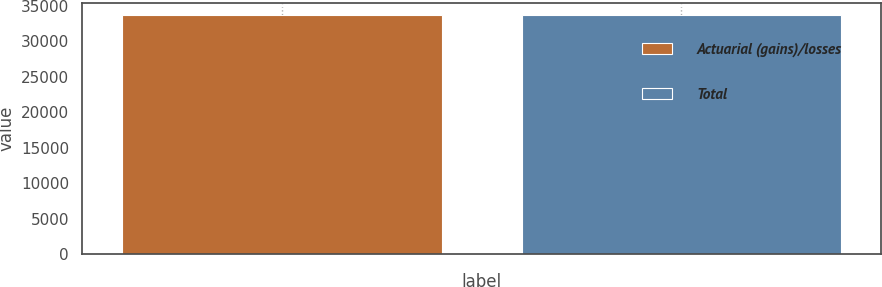Convert chart to OTSL. <chart><loc_0><loc_0><loc_500><loc_500><bar_chart><fcel>Actuarial (gains)/losses<fcel>Total<nl><fcel>33755<fcel>33755.1<nl></chart> 